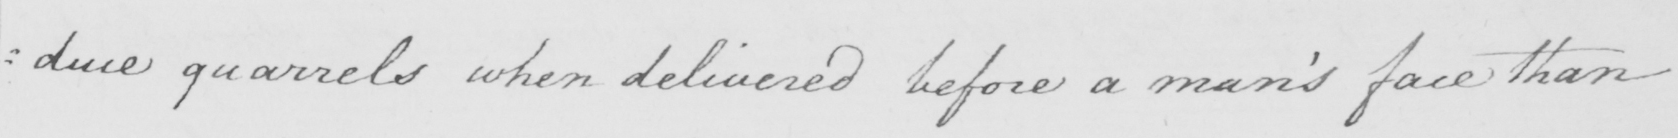What is written in this line of handwriting? : duce quarrels when delivered before a man ' s face than 